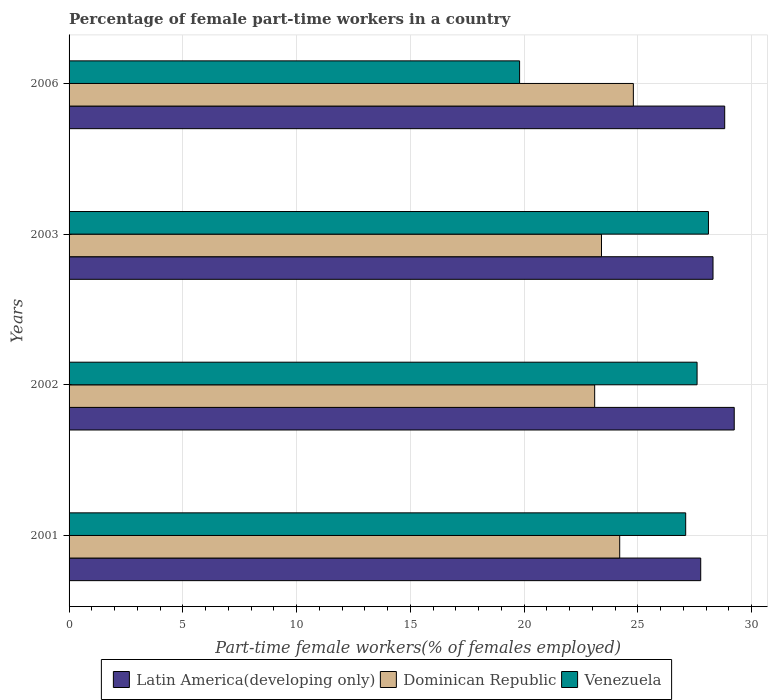How many different coloured bars are there?
Provide a succinct answer. 3. Are the number of bars per tick equal to the number of legend labels?
Provide a succinct answer. Yes. How many bars are there on the 3rd tick from the top?
Your response must be concise. 3. In how many cases, is the number of bars for a given year not equal to the number of legend labels?
Offer a very short reply. 0. What is the percentage of female part-time workers in Venezuela in 2001?
Provide a succinct answer. 27.1. Across all years, what is the maximum percentage of female part-time workers in Dominican Republic?
Make the answer very short. 24.8. Across all years, what is the minimum percentage of female part-time workers in Dominican Republic?
Provide a short and direct response. 23.1. In which year was the percentage of female part-time workers in Dominican Republic maximum?
Your answer should be very brief. 2006. What is the total percentage of female part-time workers in Dominican Republic in the graph?
Make the answer very short. 95.5. What is the difference between the percentage of female part-time workers in Dominican Republic in 2002 and that in 2006?
Keep it short and to the point. -1.7. What is the difference between the percentage of female part-time workers in Latin America(developing only) in 2006 and the percentage of female part-time workers in Venezuela in 2001?
Provide a short and direct response. 1.71. What is the average percentage of female part-time workers in Dominican Republic per year?
Provide a short and direct response. 23.88. In the year 2002, what is the difference between the percentage of female part-time workers in Dominican Republic and percentage of female part-time workers in Venezuela?
Offer a terse response. -4.5. In how many years, is the percentage of female part-time workers in Venezuela greater than 16 %?
Offer a terse response. 4. What is the ratio of the percentage of female part-time workers in Venezuela in 2003 to that in 2006?
Your answer should be very brief. 1.42. Is the difference between the percentage of female part-time workers in Dominican Republic in 2002 and 2006 greater than the difference between the percentage of female part-time workers in Venezuela in 2002 and 2006?
Offer a terse response. No. What is the difference between the highest and the second highest percentage of female part-time workers in Venezuela?
Offer a very short reply. 0.5. What is the difference between the highest and the lowest percentage of female part-time workers in Latin America(developing only)?
Provide a succinct answer. 1.47. In how many years, is the percentage of female part-time workers in Venezuela greater than the average percentage of female part-time workers in Venezuela taken over all years?
Keep it short and to the point. 3. What does the 1st bar from the top in 2002 represents?
Keep it short and to the point. Venezuela. What does the 2nd bar from the bottom in 2003 represents?
Ensure brevity in your answer.  Dominican Republic. Is it the case that in every year, the sum of the percentage of female part-time workers in Dominican Republic and percentage of female part-time workers in Venezuela is greater than the percentage of female part-time workers in Latin America(developing only)?
Provide a short and direct response. Yes. How many bars are there?
Make the answer very short. 12. What is the difference between two consecutive major ticks on the X-axis?
Your answer should be compact. 5. Are the values on the major ticks of X-axis written in scientific E-notation?
Offer a very short reply. No. Does the graph contain any zero values?
Ensure brevity in your answer.  No. Does the graph contain grids?
Make the answer very short. Yes. Where does the legend appear in the graph?
Ensure brevity in your answer.  Bottom center. What is the title of the graph?
Ensure brevity in your answer.  Percentage of female part-time workers in a country. Does "El Salvador" appear as one of the legend labels in the graph?
Your response must be concise. No. What is the label or title of the X-axis?
Your answer should be compact. Part-time female workers(% of females employed). What is the label or title of the Y-axis?
Provide a succinct answer. Years. What is the Part-time female workers(% of females employed) of Latin America(developing only) in 2001?
Keep it short and to the point. 27.76. What is the Part-time female workers(% of females employed) of Dominican Republic in 2001?
Ensure brevity in your answer.  24.2. What is the Part-time female workers(% of females employed) in Venezuela in 2001?
Make the answer very short. 27.1. What is the Part-time female workers(% of females employed) of Latin America(developing only) in 2002?
Make the answer very short. 29.23. What is the Part-time female workers(% of females employed) of Dominican Republic in 2002?
Offer a very short reply. 23.1. What is the Part-time female workers(% of females employed) in Venezuela in 2002?
Provide a short and direct response. 27.6. What is the Part-time female workers(% of females employed) in Latin America(developing only) in 2003?
Provide a succinct answer. 28.3. What is the Part-time female workers(% of females employed) in Dominican Republic in 2003?
Provide a succinct answer. 23.4. What is the Part-time female workers(% of females employed) in Venezuela in 2003?
Ensure brevity in your answer.  28.1. What is the Part-time female workers(% of females employed) of Latin America(developing only) in 2006?
Your answer should be compact. 28.81. What is the Part-time female workers(% of females employed) of Dominican Republic in 2006?
Give a very brief answer. 24.8. What is the Part-time female workers(% of females employed) of Venezuela in 2006?
Your response must be concise. 19.8. Across all years, what is the maximum Part-time female workers(% of females employed) in Latin America(developing only)?
Your answer should be very brief. 29.23. Across all years, what is the maximum Part-time female workers(% of females employed) in Dominican Republic?
Give a very brief answer. 24.8. Across all years, what is the maximum Part-time female workers(% of females employed) in Venezuela?
Your answer should be very brief. 28.1. Across all years, what is the minimum Part-time female workers(% of females employed) in Latin America(developing only)?
Your response must be concise. 27.76. Across all years, what is the minimum Part-time female workers(% of females employed) of Dominican Republic?
Provide a short and direct response. 23.1. Across all years, what is the minimum Part-time female workers(% of females employed) in Venezuela?
Provide a succinct answer. 19.8. What is the total Part-time female workers(% of females employed) in Latin America(developing only) in the graph?
Your response must be concise. 114.11. What is the total Part-time female workers(% of females employed) in Dominican Republic in the graph?
Provide a succinct answer. 95.5. What is the total Part-time female workers(% of females employed) in Venezuela in the graph?
Provide a succinct answer. 102.6. What is the difference between the Part-time female workers(% of females employed) of Latin America(developing only) in 2001 and that in 2002?
Provide a succinct answer. -1.47. What is the difference between the Part-time female workers(% of females employed) in Venezuela in 2001 and that in 2002?
Your answer should be compact. -0.5. What is the difference between the Part-time female workers(% of females employed) of Latin America(developing only) in 2001 and that in 2003?
Make the answer very short. -0.54. What is the difference between the Part-time female workers(% of females employed) of Latin America(developing only) in 2001 and that in 2006?
Offer a terse response. -1.05. What is the difference between the Part-time female workers(% of females employed) of Dominican Republic in 2001 and that in 2006?
Provide a succinct answer. -0.6. What is the difference between the Part-time female workers(% of females employed) of Latin America(developing only) in 2002 and that in 2003?
Provide a succinct answer. 0.93. What is the difference between the Part-time female workers(% of females employed) in Dominican Republic in 2002 and that in 2003?
Ensure brevity in your answer.  -0.3. What is the difference between the Part-time female workers(% of females employed) in Latin America(developing only) in 2002 and that in 2006?
Offer a very short reply. 0.42. What is the difference between the Part-time female workers(% of females employed) in Venezuela in 2002 and that in 2006?
Your response must be concise. 7.8. What is the difference between the Part-time female workers(% of females employed) of Latin America(developing only) in 2003 and that in 2006?
Provide a succinct answer. -0.51. What is the difference between the Part-time female workers(% of females employed) of Latin America(developing only) in 2001 and the Part-time female workers(% of females employed) of Dominican Republic in 2002?
Give a very brief answer. 4.66. What is the difference between the Part-time female workers(% of females employed) of Latin America(developing only) in 2001 and the Part-time female workers(% of females employed) of Venezuela in 2002?
Offer a terse response. 0.16. What is the difference between the Part-time female workers(% of females employed) in Dominican Republic in 2001 and the Part-time female workers(% of females employed) in Venezuela in 2002?
Your response must be concise. -3.4. What is the difference between the Part-time female workers(% of females employed) in Latin America(developing only) in 2001 and the Part-time female workers(% of females employed) in Dominican Republic in 2003?
Provide a succinct answer. 4.36. What is the difference between the Part-time female workers(% of females employed) of Latin America(developing only) in 2001 and the Part-time female workers(% of females employed) of Venezuela in 2003?
Your answer should be very brief. -0.34. What is the difference between the Part-time female workers(% of females employed) of Latin America(developing only) in 2001 and the Part-time female workers(% of females employed) of Dominican Republic in 2006?
Your answer should be very brief. 2.96. What is the difference between the Part-time female workers(% of females employed) in Latin America(developing only) in 2001 and the Part-time female workers(% of females employed) in Venezuela in 2006?
Provide a succinct answer. 7.96. What is the difference between the Part-time female workers(% of females employed) in Dominican Republic in 2001 and the Part-time female workers(% of females employed) in Venezuela in 2006?
Provide a short and direct response. 4.4. What is the difference between the Part-time female workers(% of females employed) in Latin America(developing only) in 2002 and the Part-time female workers(% of females employed) in Dominican Republic in 2003?
Keep it short and to the point. 5.83. What is the difference between the Part-time female workers(% of females employed) in Latin America(developing only) in 2002 and the Part-time female workers(% of females employed) in Venezuela in 2003?
Provide a succinct answer. 1.13. What is the difference between the Part-time female workers(% of females employed) of Dominican Republic in 2002 and the Part-time female workers(% of females employed) of Venezuela in 2003?
Your answer should be compact. -5. What is the difference between the Part-time female workers(% of females employed) of Latin America(developing only) in 2002 and the Part-time female workers(% of females employed) of Dominican Republic in 2006?
Make the answer very short. 4.43. What is the difference between the Part-time female workers(% of females employed) in Latin America(developing only) in 2002 and the Part-time female workers(% of females employed) in Venezuela in 2006?
Provide a short and direct response. 9.43. What is the difference between the Part-time female workers(% of females employed) in Latin America(developing only) in 2003 and the Part-time female workers(% of females employed) in Dominican Republic in 2006?
Offer a terse response. 3.5. What is the difference between the Part-time female workers(% of females employed) of Latin America(developing only) in 2003 and the Part-time female workers(% of females employed) of Venezuela in 2006?
Provide a short and direct response. 8.5. What is the difference between the Part-time female workers(% of females employed) in Dominican Republic in 2003 and the Part-time female workers(% of females employed) in Venezuela in 2006?
Make the answer very short. 3.6. What is the average Part-time female workers(% of females employed) of Latin America(developing only) per year?
Offer a very short reply. 28.53. What is the average Part-time female workers(% of females employed) in Dominican Republic per year?
Offer a very short reply. 23.88. What is the average Part-time female workers(% of females employed) in Venezuela per year?
Give a very brief answer. 25.65. In the year 2001, what is the difference between the Part-time female workers(% of females employed) in Latin America(developing only) and Part-time female workers(% of females employed) in Dominican Republic?
Offer a very short reply. 3.56. In the year 2001, what is the difference between the Part-time female workers(% of females employed) in Latin America(developing only) and Part-time female workers(% of females employed) in Venezuela?
Provide a short and direct response. 0.66. In the year 2002, what is the difference between the Part-time female workers(% of females employed) of Latin America(developing only) and Part-time female workers(% of females employed) of Dominican Republic?
Keep it short and to the point. 6.13. In the year 2002, what is the difference between the Part-time female workers(% of females employed) in Latin America(developing only) and Part-time female workers(% of females employed) in Venezuela?
Provide a succinct answer. 1.63. In the year 2003, what is the difference between the Part-time female workers(% of females employed) of Latin America(developing only) and Part-time female workers(% of females employed) of Dominican Republic?
Your response must be concise. 4.9. In the year 2003, what is the difference between the Part-time female workers(% of females employed) in Latin America(developing only) and Part-time female workers(% of females employed) in Venezuela?
Ensure brevity in your answer.  0.2. In the year 2003, what is the difference between the Part-time female workers(% of females employed) in Dominican Republic and Part-time female workers(% of females employed) in Venezuela?
Give a very brief answer. -4.7. In the year 2006, what is the difference between the Part-time female workers(% of females employed) of Latin America(developing only) and Part-time female workers(% of females employed) of Dominican Republic?
Offer a terse response. 4.01. In the year 2006, what is the difference between the Part-time female workers(% of females employed) in Latin America(developing only) and Part-time female workers(% of females employed) in Venezuela?
Provide a succinct answer. 9.01. What is the ratio of the Part-time female workers(% of females employed) in Latin America(developing only) in 2001 to that in 2002?
Give a very brief answer. 0.95. What is the ratio of the Part-time female workers(% of females employed) of Dominican Republic in 2001 to that in 2002?
Your answer should be very brief. 1.05. What is the ratio of the Part-time female workers(% of females employed) of Venezuela in 2001 to that in 2002?
Provide a succinct answer. 0.98. What is the ratio of the Part-time female workers(% of females employed) in Latin America(developing only) in 2001 to that in 2003?
Provide a succinct answer. 0.98. What is the ratio of the Part-time female workers(% of females employed) in Dominican Republic in 2001 to that in 2003?
Provide a succinct answer. 1.03. What is the ratio of the Part-time female workers(% of females employed) in Venezuela in 2001 to that in 2003?
Ensure brevity in your answer.  0.96. What is the ratio of the Part-time female workers(% of females employed) of Latin America(developing only) in 2001 to that in 2006?
Offer a very short reply. 0.96. What is the ratio of the Part-time female workers(% of females employed) of Dominican Republic in 2001 to that in 2006?
Ensure brevity in your answer.  0.98. What is the ratio of the Part-time female workers(% of females employed) in Venezuela in 2001 to that in 2006?
Your response must be concise. 1.37. What is the ratio of the Part-time female workers(% of females employed) in Latin America(developing only) in 2002 to that in 2003?
Keep it short and to the point. 1.03. What is the ratio of the Part-time female workers(% of females employed) of Dominican Republic in 2002 to that in 2003?
Give a very brief answer. 0.99. What is the ratio of the Part-time female workers(% of females employed) in Venezuela in 2002 to that in 2003?
Keep it short and to the point. 0.98. What is the ratio of the Part-time female workers(% of females employed) of Latin America(developing only) in 2002 to that in 2006?
Offer a very short reply. 1.01. What is the ratio of the Part-time female workers(% of females employed) of Dominican Republic in 2002 to that in 2006?
Give a very brief answer. 0.93. What is the ratio of the Part-time female workers(% of females employed) in Venezuela in 2002 to that in 2006?
Keep it short and to the point. 1.39. What is the ratio of the Part-time female workers(% of females employed) of Latin America(developing only) in 2003 to that in 2006?
Your response must be concise. 0.98. What is the ratio of the Part-time female workers(% of females employed) in Dominican Republic in 2003 to that in 2006?
Ensure brevity in your answer.  0.94. What is the ratio of the Part-time female workers(% of females employed) of Venezuela in 2003 to that in 2006?
Give a very brief answer. 1.42. What is the difference between the highest and the second highest Part-time female workers(% of females employed) of Latin America(developing only)?
Ensure brevity in your answer.  0.42. What is the difference between the highest and the second highest Part-time female workers(% of females employed) in Dominican Republic?
Provide a short and direct response. 0.6. What is the difference between the highest and the lowest Part-time female workers(% of females employed) of Latin America(developing only)?
Provide a succinct answer. 1.47. 